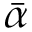Convert formula to latex. <formula><loc_0><loc_0><loc_500><loc_500>\bar { \alpha }</formula> 